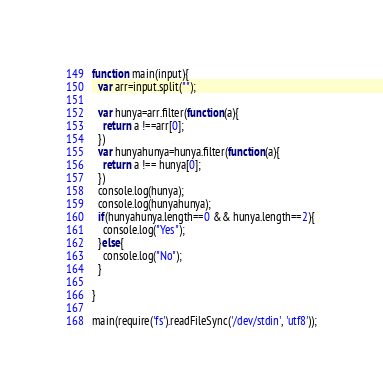Convert code to text. <code><loc_0><loc_0><loc_500><loc_500><_JavaScript_>function main(input){
  var arr=input.split("");

  var hunya=arr.filter(function(a){
    return a !==arr[0];
  })
  var hunyahunya=hunya.filter(function(a){
    return a !== hunya[0];
  })
  console.log(hunya);
  console.log(hunyahunya);
  if(hunyahunya.length==0 && hunya.length==2){
    console.log("Yes");
  }else{
    console.log("No");
  }

}

main(require('fs').readFileSync('/dev/stdin', 'utf8'));</code> 